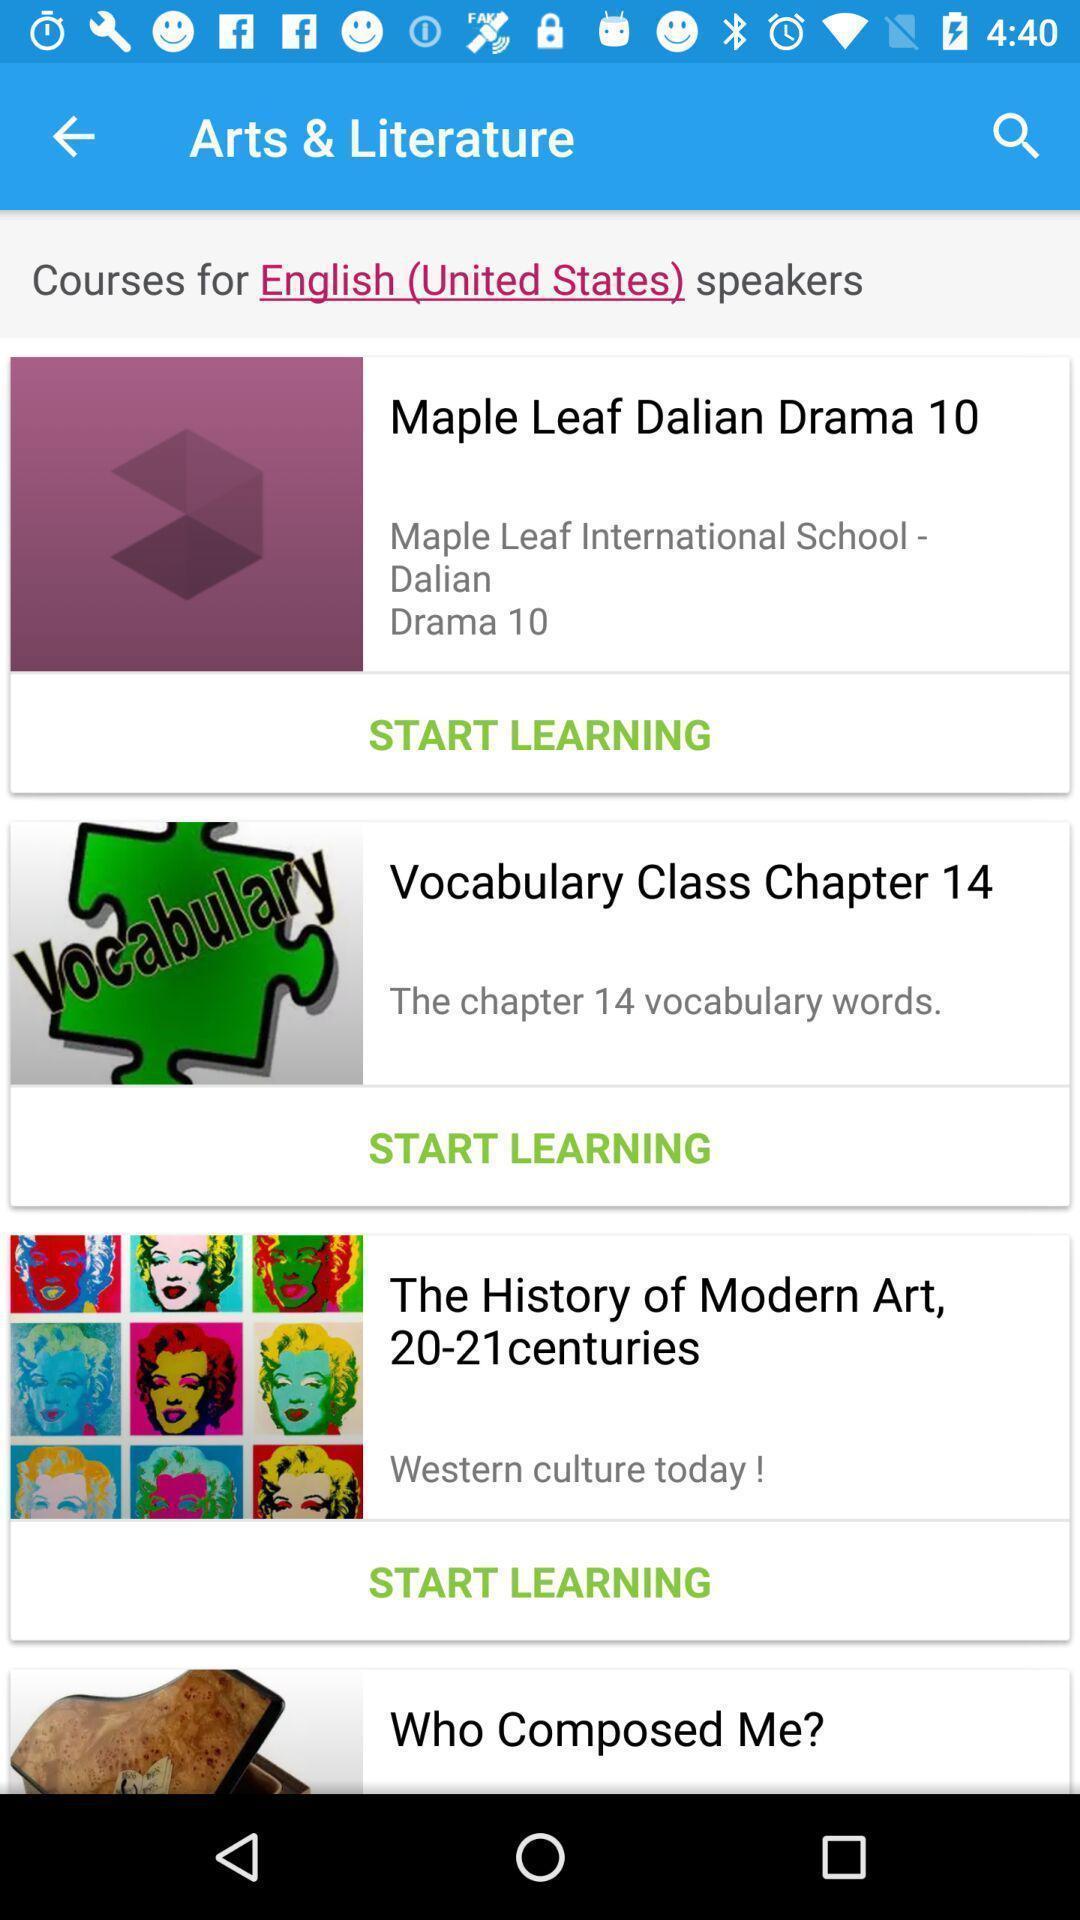Describe this image in words. Page displaying various categories in learning application. 